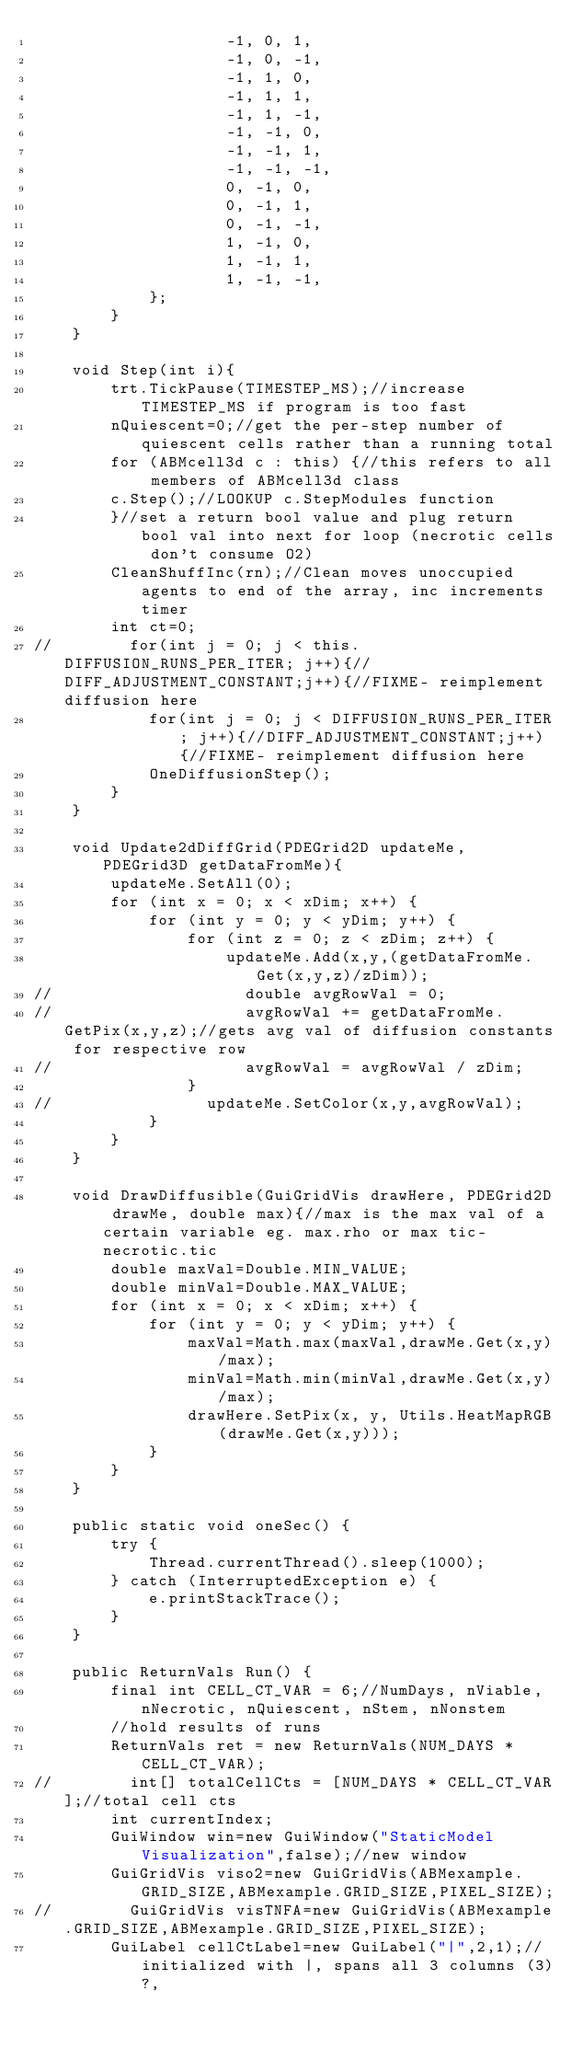<code> <loc_0><loc_0><loc_500><loc_500><_Java_>                    -1, 0, 1,
                    -1, 0, -1,
                    -1, 1, 0,
                    -1, 1, 1,
                    -1, 1, -1,
                    -1, -1, 0,
                    -1, -1, 1,
                    -1, -1, -1,
                    0, -1, 0,
                    0, -1, 1,
                    0, -1, -1,
                    1, -1, 0,
                    1, -1, 1,
                    1, -1, -1,
            };
        }
    }

    void Step(int i){
        trt.TickPause(TIMESTEP_MS);//increase TIMESTEP_MS if program is too fast
        nQuiescent=0;//get the per-step number of quiescent cells rather than a running total
        for (ABMcell3d c : this) {//this refers to all members of ABMcell3d class
        c.Step();//LOOKUP c.StepModules function
        }//set a return bool value and plug return bool val into next for loop (necrotic cells don't consume O2)
        CleanShuffInc(rn);//Clean moves unoccupied agents to end of the array, inc increments timer
        int ct=0;
//        for(int j = 0; j < this.DIFFUSION_RUNS_PER_ITER; j++){//DIFF_ADJUSTMENT_CONSTANT;j++){//FIXME- reimplement diffusion here
            for(int j = 0; j < DIFFUSION_RUNS_PER_ITER; j++){//DIFF_ADJUSTMENT_CONSTANT;j++){//FIXME- reimplement diffusion here
            OneDiffusionStep();
        }
    }

    void Update2dDiffGrid(PDEGrid2D updateMe, PDEGrid3D getDataFromMe){
        updateMe.SetAll(0);
        for (int x = 0; x < xDim; x++) {
            for (int y = 0; y < yDim; y++) {
                for (int z = 0; z < zDim; z++) {
                    updateMe.Add(x,y,(getDataFromMe.Get(x,y,z)/zDim));
//                    double avgRowVal = 0;
//                    avgRowVal += getDataFromMe.GetPix(x,y,z);//gets avg val of diffusion constants for respective row
//                    avgRowVal = avgRowVal / zDim;
                }
//                updateMe.SetColor(x,y,avgRowVal);
            }
        }
    }

    void DrawDiffusible(GuiGridVis drawHere, PDEGrid2D drawMe, double max){//max is the max val of a certain variable eg. max.rho or max tic-necrotic.tic
        double maxVal=Double.MIN_VALUE;
        double minVal=Double.MAX_VALUE;
        for (int x = 0; x < xDim; x++) {
            for (int y = 0; y < yDim; y++) {
                maxVal=Math.max(maxVal,drawMe.Get(x,y)/max);
                minVal=Math.min(minVal,drawMe.Get(x,y)/max);
                drawHere.SetPix(x, y, Utils.HeatMapRGB(drawMe.Get(x,y)));
            }
        }
    }

    public static void oneSec() {
        try {
            Thread.currentThread().sleep(1000);
        } catch (InterruptedException e) {
            e.printStackTrace();
        }
    }

    public ReturnVals Run() {
        final int CELL_CT_VAR = 6;//NumDays, nViable, nNecrotic, nQuiescent, nStem, nNonstem
        //hold results of runs
        ReturnVals ret = new ReturnVals(NUM_DAYS * CELL_CT_VAR);
//        int[] totalCellCts = [NUM_DAYS * CELL_CT_VAR];//total cell cts
        int currentIndex;
        GuiWindow win=new GuiWindow("StaticModel Visualization",false);//new window
        GuiGridVis viso2=new GuiGridVis(ABMexample.GRID_SIZE,ABMexample.GRID_SIZE,PIXEL_SIZE);
//        GuiGridVis visTNFA=new GuiGridVis(ABMexample.GRID_SIZE,ABMexample.GRID_SIZE,PIXEL_SIZE);
        GuiLabel cellCtLabel=new GuiLabel("|",2,1);//initialized with |, spans all 3 columns (3)?,</code> 